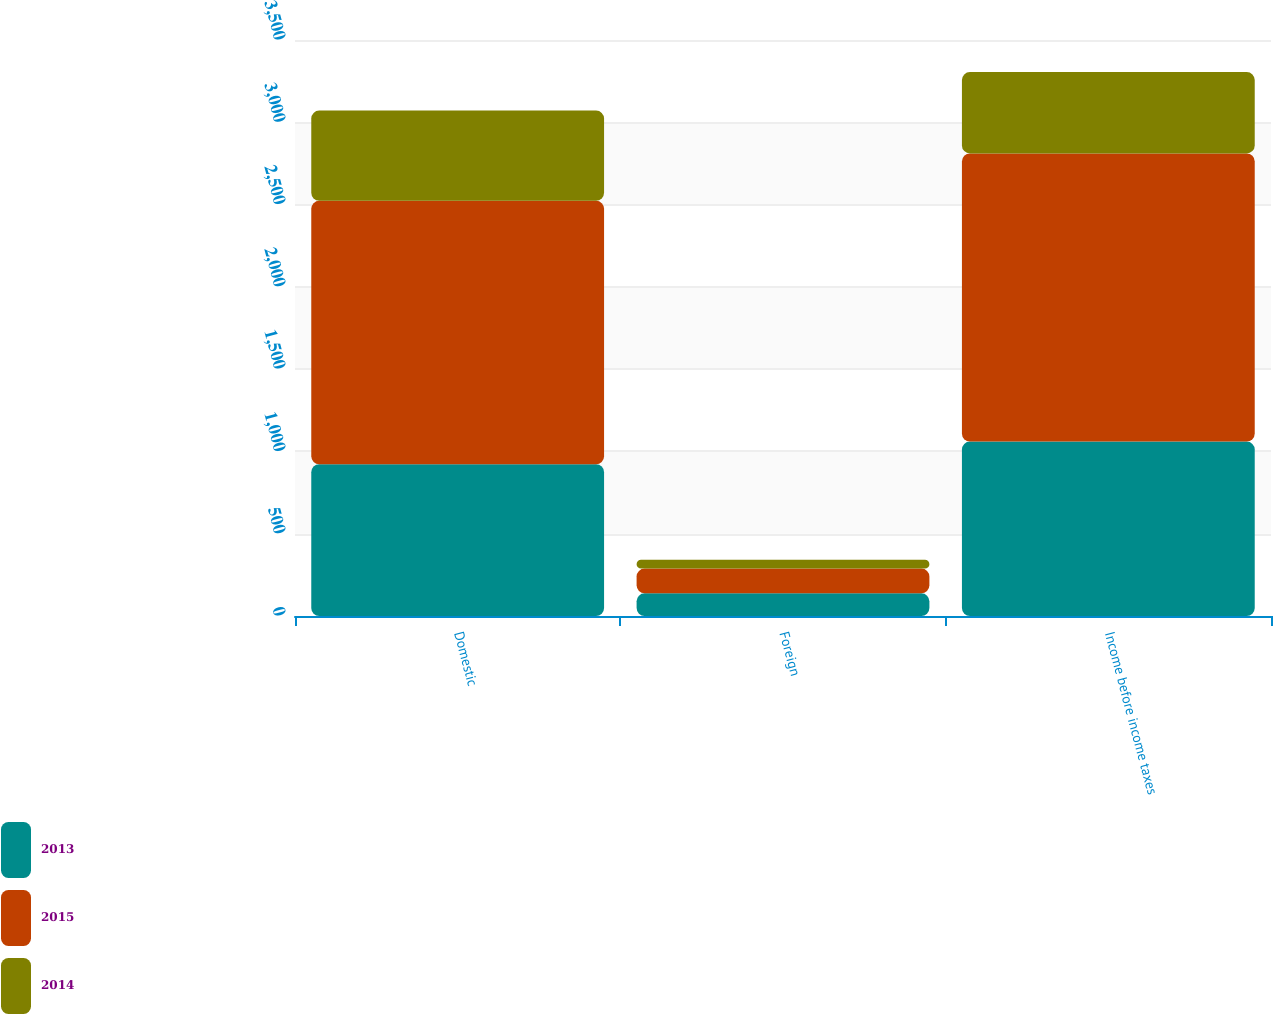<chart> <loc_0><loc_0><loc_500><loc_500><stacked_bar_chart><ecel><fcel>Domestic<fcel>Foreign<fcel>Income before income taxes<nl><fcel>2013<fcel>922<fcel>138<fcel>1060<nl><fcel>2015<fcel>1601<fcel>150<fcel>1751<nl><fcel>2014<fcel>548<fcel>54<fcel>494<nl></chart> 